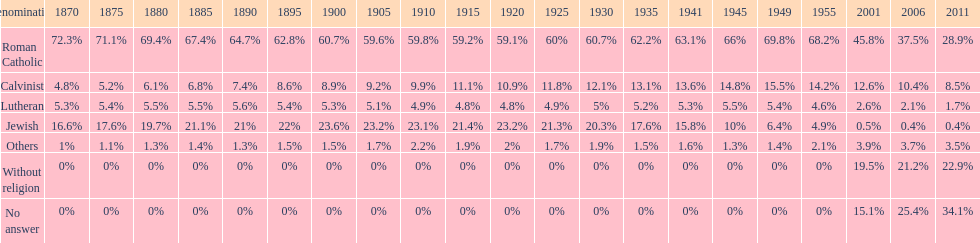Help me parse the entirety of this table. {'header': ['Denomination', '1870', '1875', '1880', '1885', '1890', '1895', '1900', '1905', '1910', '1915', '1920', '1925', '1930', '1935', '1941', '1945', '1949', '1955', '2001', '2006', '2011'], 'rows': [['Roman Catholic', '72.3%', '71.1%', '69.4%', '67.4%', '64.7%', '62.8%', '60.7%', '59.6%', '59.8%', '59.2%', '59.1%', '60%', '60.7%', '62.2%', '63.1%', '66%', '69.8%', '68.2%', '45.8%', '37.5%', '28.9%'], ['Calvinist', '4.8%', '5.2%', '6.1%', '6.8%', '7.4%', '8.6%', '8.9%', '9.2%', '9.9%', '11.1%', '10.9%', '11.8%', '12.1%', '13.1%', '13.6%', '14.8%', '15.5%', '14.2%', '12.6%', '10.4%', '8.5%'], ['Lutheran', '5.3%', '5.4%', '5.5%', '5.5%', '5.6%', '5.4%', '5.3%', '5.1%', '4.9%', '4.8%', '4.8%', '4.9%', '5%', '5.2%', '5.3%', '5.5%', '5.4%', '4.6%', '2.6%', '2.1%', '1.7%'], ['Jewish', '16.6%', '17.6%', '19.7%', '21.1%', '21%', '22%', '23.6%', '23.2%', '23.1%', '21.4%', '23.2%', '21.3%', '20.3%', '17.6%', '15.8%', '10%', '6.4%', '4.9%', '0.5%', '0.4%', '0.4%'], ['Others', '1%', '1.1%', '1.3%', '1.4%', '1.3%', '1.5%', '1.5%', '1.7%', '2.2%', '1.9%', '2%', '1.7%', '1.9%', '1.5%', '1.6%', '1.3%', '1.4%', '2.1%', '3.9%', '3.7%', '3.5%'], ['Without religion', '0%', '0%', '0%', '0%', '0%', '0%', '0%', '0%', '0%', '0%', '0%', '0%', '0%', '0%', '0%', '0%', '0%', '0%', '19.5%', '21.2%', '22.9%'], ['No answer', '0%', '0%', '0%', '0%', '0%', '0%', '0%', '0%', '0%', '0%', '0%', '0%', '0%', '0%', '0%', '0%', '0%', '0%', '15.1%', '25.4%', '34.1%']]} Which religious denomination had a higher percentage in 1900, jewish or roman catholic? Roman Catholic. 